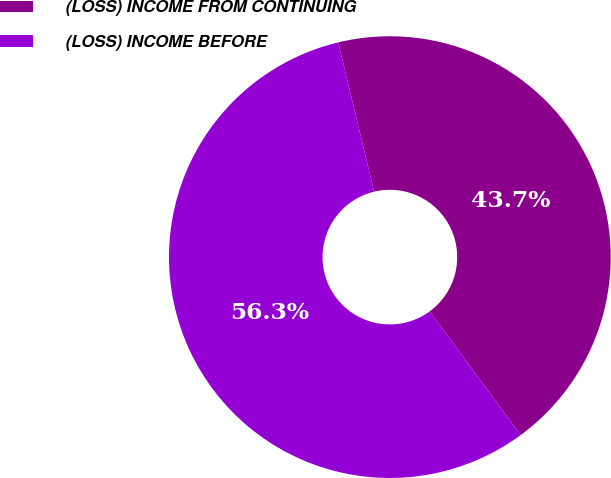Convert chart. <chart><loc_0><loc_0><loc_500><loc_500><pie_chart><fcel>(LOSS) INCOME FROM CONTINUING<fcel>(LOSS) INCOME BEFORE<nl><fcel>43.67%<fcel>56.33%<nl></chart> 